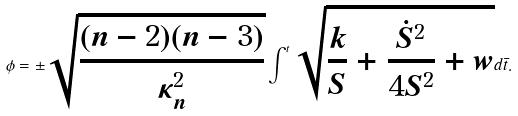<formula> <loc_0><loc_0><loc_500><loc_500>\phi = \pm \sqrt { \frac { ( n - 2 ) ( n - 3 ) } { \kappa _ { n } ^ { 2 } } } \int ^ { t } \sqrt { \frac { k } { S } + \frac { { \dot { S } } ^ { 2 } } { 4 S ^ { 2 } } + w } d { \bar { t } } .</formula> 